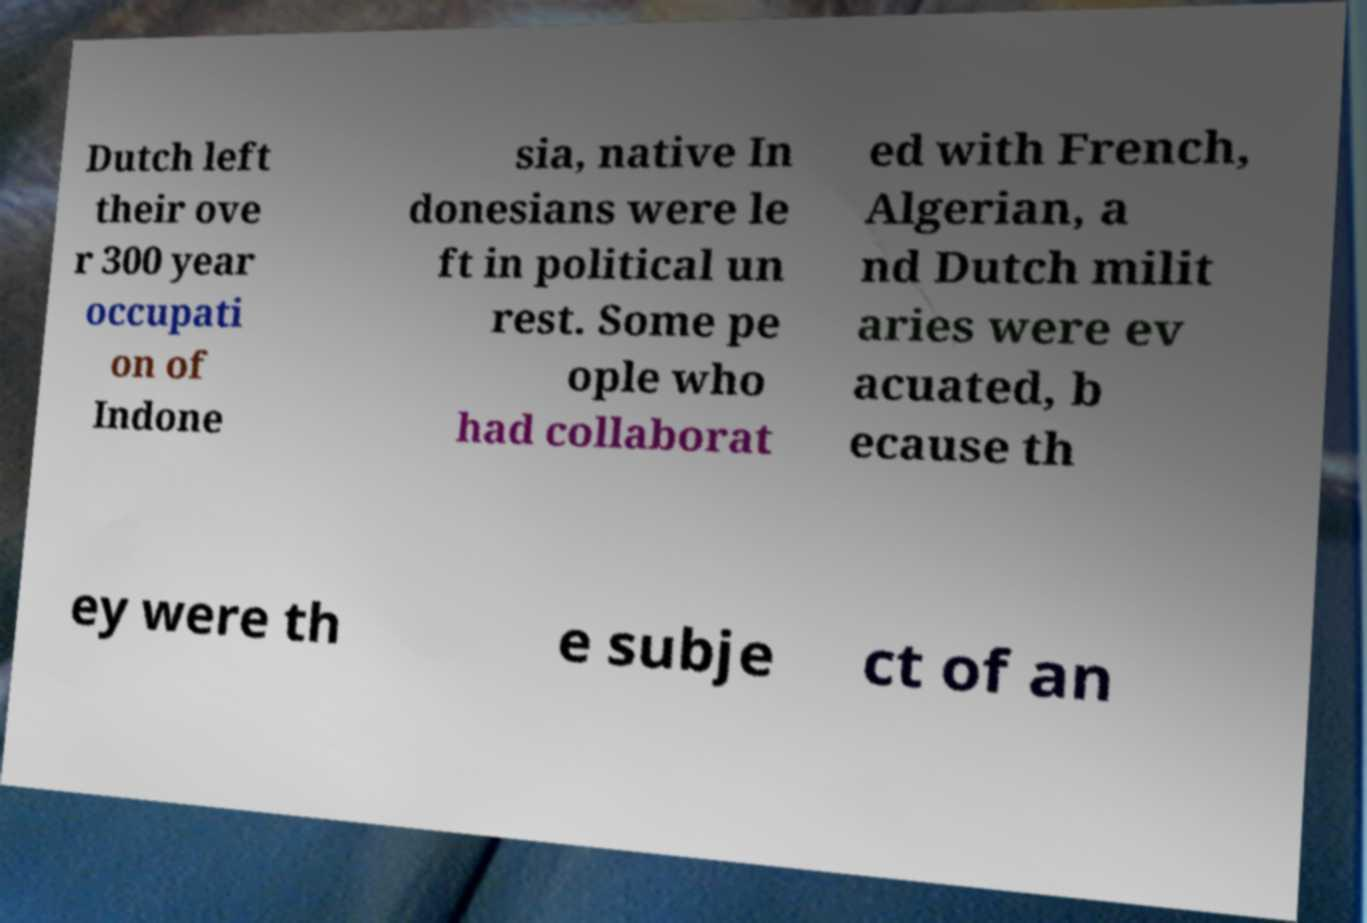Please identify and transcribe the text found in this image. Dutch left their ove r 300 year occupati on of Indone sia, native In donesians were le ft in political un rest. Some pe ople who had collaborat ed with French, Algerian, a nd Dutch milit aries were ev acuated, b ecause th ey were th e subje ct of an 